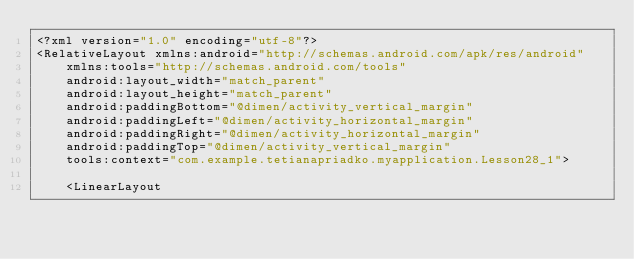<code> <loc_0><loc_0><loc_500><loc_500><_XML_><?xml version="1.0" encoding="utf-8"?>
<RelativeLayout xmlns:android="http://schemas.android.com/apk/res/android"
    xmlns:tools="http://schemas.android.com/tools"
    android:layout_width="match_parent"
    android:layout_height="match_parent"
    android:paddingBottom="@dimen/activity_vertical_margin"
    android:paddingLeft="@dimen/activity_horizontal_margin"
    android:paddingRight="@dimen/activity_horizontal_margin"
    android:paddingTop="@dimen/activity_vertical_margin"
    tools:context="com.example.tetianapriadko.myapplication.Lesson28_1">

    <LinearLayout</code> 